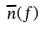Convert formula to latex. <formula><loc_0><loc_0><loc_500><loc_500>\overline { n } ( f )</formula> 